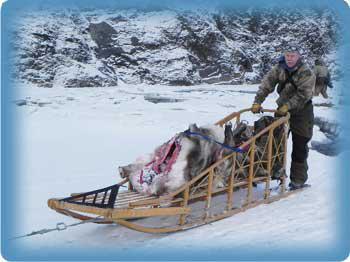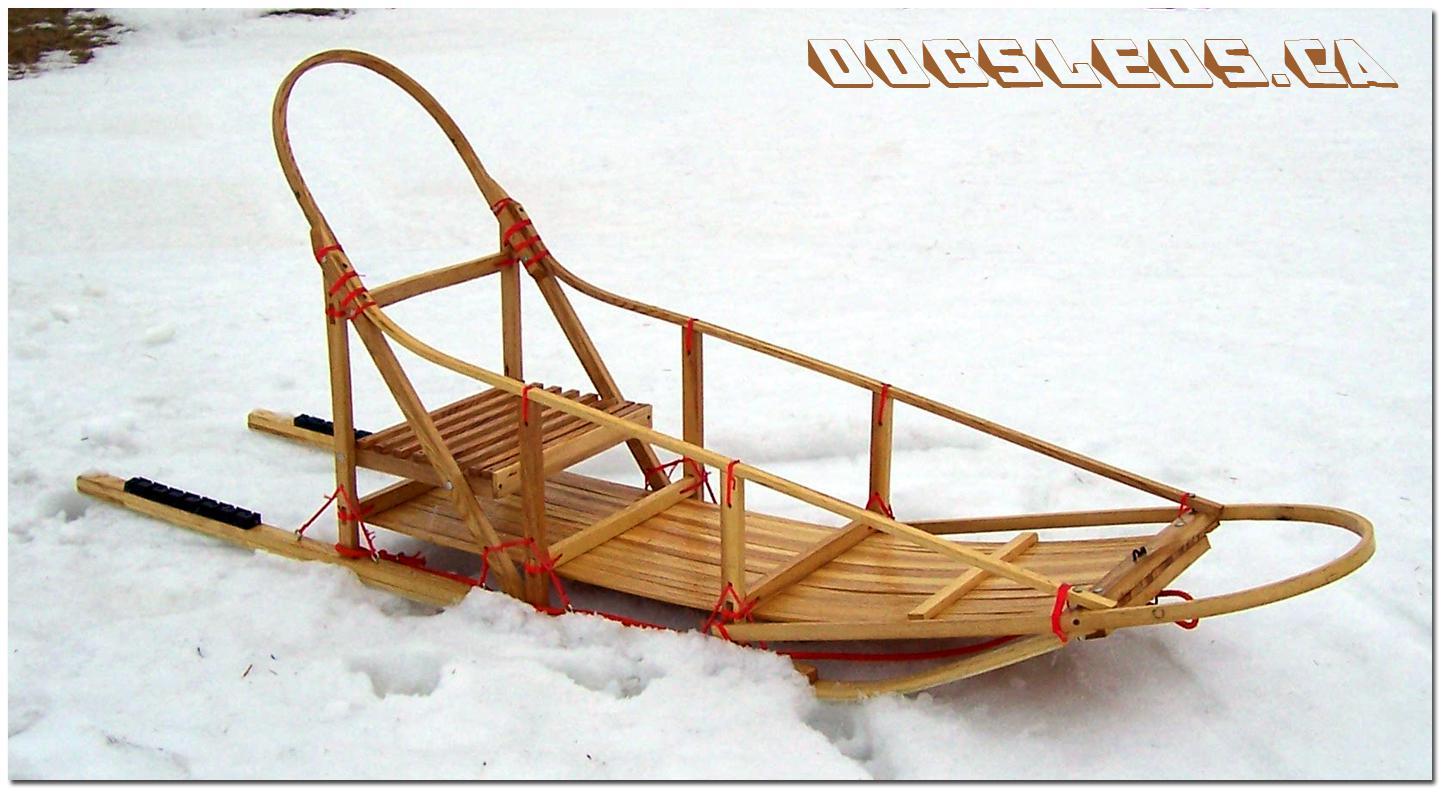The first image is the image on the left, the second image is the image on the right. Evaluate the accuracy of this statement regarding the images: "There is a human looking at a sled in one of the images.". Is it true? Answer yes or no. Yes. 